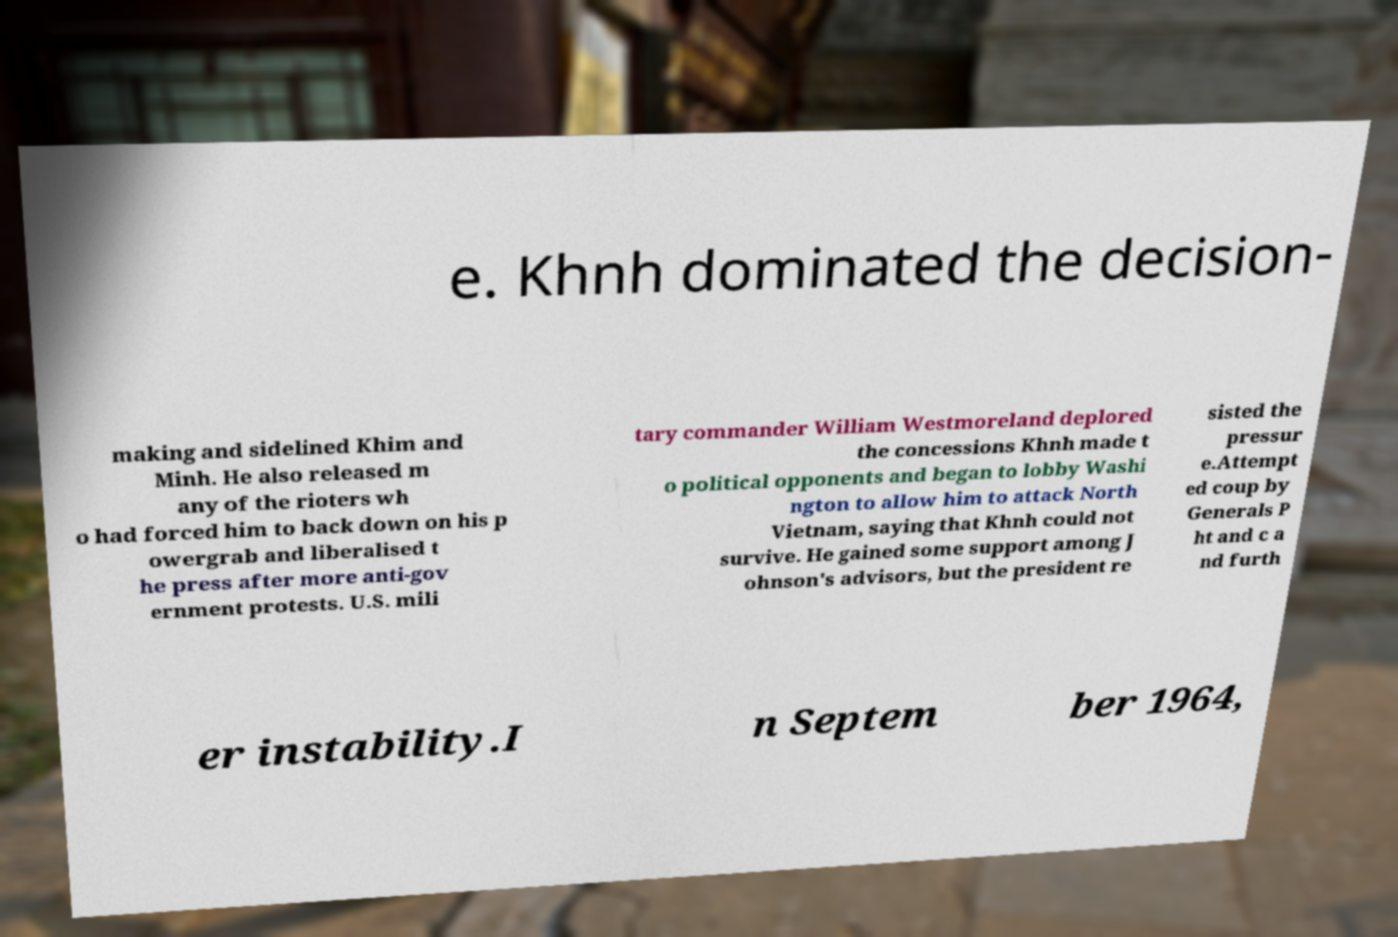Please read and relay the text visible in this image. What does it say? e. Khnh dominated the decision- making and sidelined Khim and Minh. He also released m any of the rioters wh o had forced him to back down on his p owergrab and liberalised t he press after more anti-gov ernment protests. U.S. mili tary commander William Westmoreland deplored the concessions Khnh made t o political opponents and began to lobby Washi ngton to allow him to attack North Vietnam, saying that Khnh could not survive. He gained some support among J ohnson's advisors, but the president re sisted the pressur e.Attempt ed coup by Generals P ht and c a nd furth er instability.I n Septem ber 1964, 